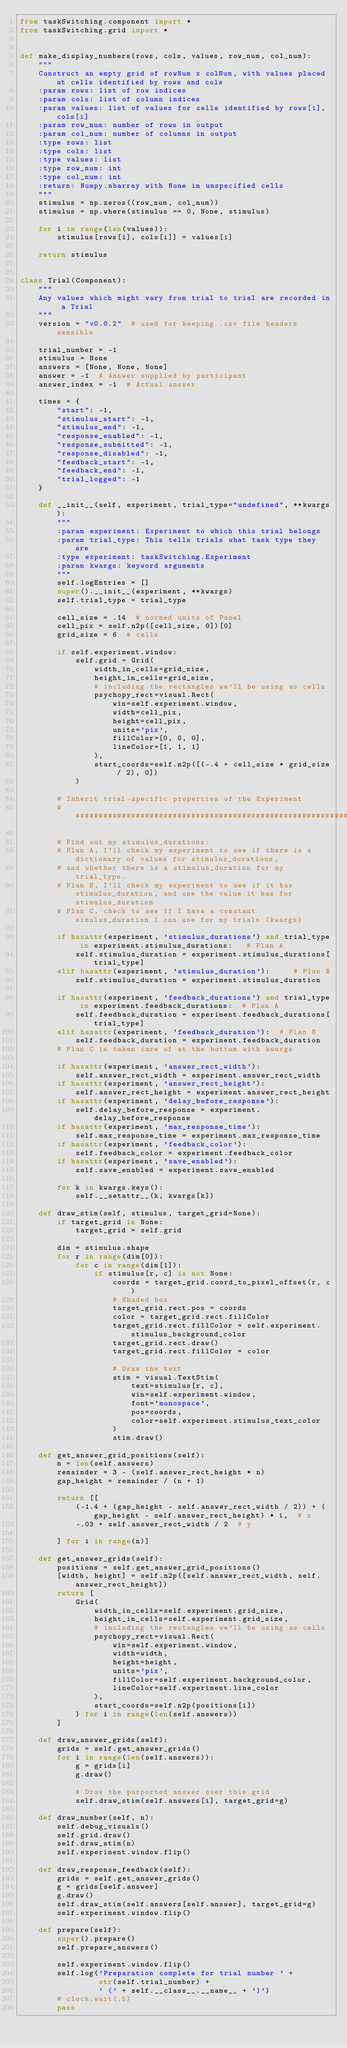<code> <loc_0><loc_0><loc_500><loc_500><_Python_>from taskSwitching.component import *
from taskSwitching.grid import *


def make_display_numbers(rows, cols, values, row_num, col_num):
    """
    Construct an empty grid of rowNum x colNum, with values placed at cells identified by rows and cols
    :param rows: list of row indices
    :param cols: list of column indices
    :param values: list of values for cells identified by rows[i], cols[i]
    :param row_num: number of rows in output
    :param col_num: number of columns in output
    :type rows: list
    :type cols: list
    :type values: list
    :type row_num: int
    :type col_num: int
    :return: Numpy.nbarray with None in unspecified cells
    """
    stimulus = np.zeros((row_num, col_num))
    stimulus = np.where(stimulus == 0, None, stimulus)

    for i in range(len(values)):
        stimulus[rows[i], cols[i]] = values[i]

    return stimulus


class Trial(Component):
    """
    Any values which might vary from trial to trial are recorded in a Trial
    """
    version = "v0.0.2"  # used for keeping .csv file headers sensible

    trial_number = -1
    stimulus = None
    answers = [None, None, None]
    answer = -1  # Answer supplied by participant
    answer_index = -1  # Actual answer

    times = {
        "start": -1,
        "stimulus_start": -1,
        "stimulus_end": -1,
        "response_enabled": -1,
        "response_submitted": -1,
        "response_disabled": -1,
        "feedback_start": -1,
        "feedback_end": -1,
        "trial_logged": -1
    }

    def __init__(self, experiment, trial_type="undefined", **kwargs):
        """
        :param experiment: Experiment to which this trial belongs
        :param trial_type: This tells trials what task type they are 
        :type experiment: taskSwitching.Experiment
        :param kwargs: keyword arguments
        """
        self.logEntries = []
        super().__init__(experiment, **kwargs)
        self.trial_type = trial_type

        cell_size = .14  # normed units of Panel
        cell_pix = self.n2p([cell_size, 0])[0]
        grid_size = 6  # cells

        if self.experiment.window:
            self.grid = Grid(
                width_in_cells=grid_size,
                height_in_cells=grid_size,
                # including the rectangles we'll be using as cells
                psychopy_rect=visual.Rect(
                    win=self.experiment.window,
                    width=cell_pix,
                    height=cell_pix,
                    units='pix',
                    fillColor=[0, 0, 0],
                    lineColor=[1, 1, 1]
                ),
                start_coords=self.n2p([(-.4 + cell_size * grid_size / 2), 0])
            )

        # Inherit trial-specific properties of the Experiment
        ########################################################################################

        # Find out my stimulus_durations:
        # Plan A, I'll check my experiment to see if there is a dictionary of values for stimulus_durations,  
        # and whether there is a stimulus_duration for my trial_type. 
        # Plan B, I'll check my experiment to see if it has stimulus_duration, and use the value it has for stimulus_duration  
        # Plan C, check to see if I have a constant simulus_duration I can use for my trials (kwargs)

        if hasattr(experiment, 'stimulus_durations') and trial_type in experiment.stimulus_durations:   # Plan A
            self.stimulus_duration = experiment.stimulus_durations[trial_type]  
        elif hasattr(experiment, 'stimulus_duration'):     # Plan B
            self.stimulus_duration = experiment.stimulus_duration

        if hasattr(experiment, 'feedback_durations') and trial_type in experiment.feedback_durations:  # Plan A
            self.feedback_duration = experiment.feedback_durations[trial_type]
        elif hasattr(experiment, 'feedback_duration'):  # Plan B
            self.feedback_duration = experiment.feedback_duration
        # Plan C is taken care of at the bottom with kwargs

        if hasattr(experiment, 'answer_rect_width'):
            self.answer_rect_width = experiment.answer_rect_width
        if hasattr(experiment, 'answer_rect_height'):
            self.answer_rect_height = experiment.answer_rect_height
        if hasattr(experiment, 'delay_before_response'):
            self.delay_before_response = experiment.delay_before_response
        if hasattr(experiment, 'max_response_time'):
            self.max_response_time = experiment.max_response_time
        if hasattr(experiment, 'feedback_color'):
            self.feedback_color = experiment.feedback_color
        if hasattr(experiment, 'save_enabled'):
            self.save_enabled = experiment.save_enabled

        for k in kwargs.keys():
            self.__setattr__(k, kwargs[k])

    def draw_stim(self, stimulus, target_grid=None):
        if target_grid is None:
            target_grid = self.grid

        dim = stimulus.shape
        for r in range(dim[0]):
            for c in range(dim[1]):
                if stimulus[r, c] is not None:
                    coords = target_grid.coord_to_pixel_offset(r, c)
                    # Shaded box
                    target_grid.rect.pos = coords
                    color = target_grid.rect.fillColor
                    target_grid.rect.fillColor = self.experiment.stimulus_background_color
                    target_grid.rect.draw()
                    target_grid.rect.fillColor = color

                    # Draw the text
                    stim = visual.TextStim(
                        text=stimulus[r, c],
                        win=self.experiment.window,
                        font='monospace',
                        pos=coords,
                        color=self.experiment.stimulus_text_color
                    )
                    stim.draw()

    def get_answer_grid_positions(self):
        n = len(self.answers)
        remainder = 3 - (self.answer_rect_height * n)
        gap_height = remainder / (n + 1)
        
        return [[
            (-1.4 + (gap_height - self.answer_rect_width / 2)) + (gap_height - self.answer_rect_height) * i,  # x
            -.03 + self.answer_rect_width / 2  # y

        ] for i in range(n)]

    def get_answer_grids(self):
        positions = self.get_answer_grid_positions()
        [width, height] = self.n2p([self.answer_rect_width, self.answer_rect_height])
        return [
            Grid(
                width_in_cells=self.experiment.grid_size,
                height_in_cells=self.experiment.grid_size,
                # including the rectangles we'll be using as cells
                psychopy_rect=visual.Rect(
                    win=self.experiment.window,
                    width=width,
                    height=height,
                    units='pix',
                    fillColor=self.experiment.background_color,
                    lineColor=self.experiment.line_color
                ),
                start_coords=self.n2p(positions[i])
            ) for i in range(len(self.answers))
        ]

    def draw_answer_grids(self):
        grids = self.get_answer_grids()
        for i in range(len(self.answers)):
            g = grids[i]
            g.draw()

            # Draw the purported answer over this grid
            self.draw_stim(self.answers[i], target_grid=g)

    def draw_number(self, n):
        self.debug_visuals()
        self.grid.draw()
        self.draw_stim(n)
        self.experiment.window.flip()

    def draw_response_feedback(self):
        grids = self.get_answer_grids()
        g = grids[self.answer]
        g.draw()
        self.draw_stim(self.answers[self.answer], target_grid=g)
        self.experiment.window.flip()

    def prepare(self):
        super().prepare()
        self.prepare_answers()

        self.experiment.window.flip()
        self.log('Preparation complete for trial number ' +
                 str(self.trial_number) +
                 ' (' + self.__class__.__name__ + ')')
        # clock.wait(.5)
        pass
</code> 